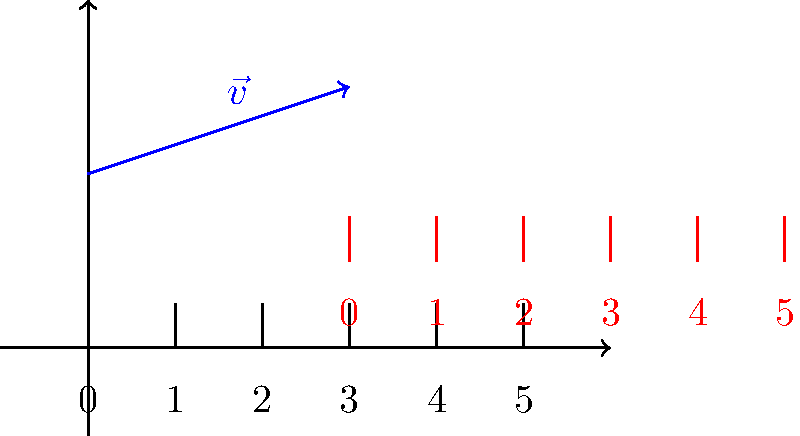In your stationery store, you're designing a ruler-themed bookmark. To create an interesting pattern, you need to translate a geometric ruler pattern along a vector. Given the initial ruler pattern and the translation vector $\vec{v}$ shown in blue, determine the coordinates of the point labeled '3' on the translated ruler (shown in red). To find the coordinates of the point labeled '3' on the translated ruler, we need to follow these steps:

1. Identify the initial position of the point labeled '3' on the original ruler:
   The initial coordinates are $(3, 0)$.

2. Determine the translation vector $\vec{v}$:
   The vector starts at $(0, 2)$ and ends at $(3, 3)$.
   $\vec{v} = (3 - 0, 3 - 2) = (3, 1)$

3. Apply the translation to the initial point:
   New coordinates = Initial coordinates + Translation vector
   $(x', y') = (x, y) + (3, 1)$
   $(x', y') = (3, 0) + (3, 1)$
   $(x', y') = (6, 1)$

Therefore, the coordinates of the point labeled '3' on the translated ruler are $(6, 1)$.
Answer: $(6, 1)$ 